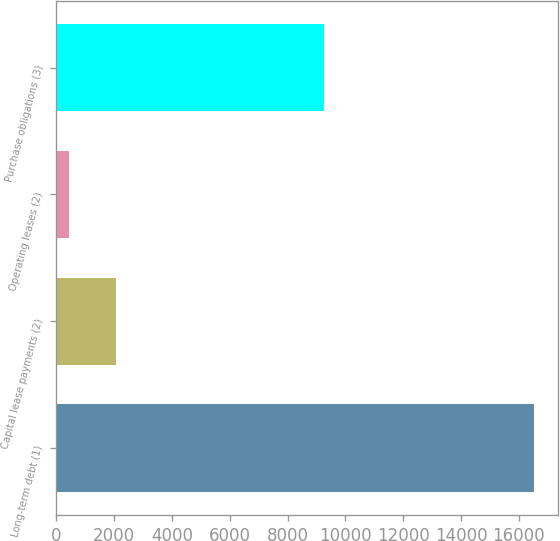Convert chart to OTSL. <chart><loc_0><loc_0><loc_500><loc_500><bar_chart><fcel>Long-term debt (1)<fcel>Capital lease payments (2)<fcel>Operating leases (2)<fcel>Purchase obligations (3)<nl><fcel>16516<fcel>2054.8<fcel>448<fcel>9250<nl></chart> 